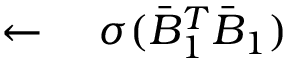<formula> <loc_0><loc_0><loc_500><loc_500>\leftarrow \quad \sigma ( \bar { B } _ { 1 } ^ { T } \bar { B } _ { 1 } )</formula> 